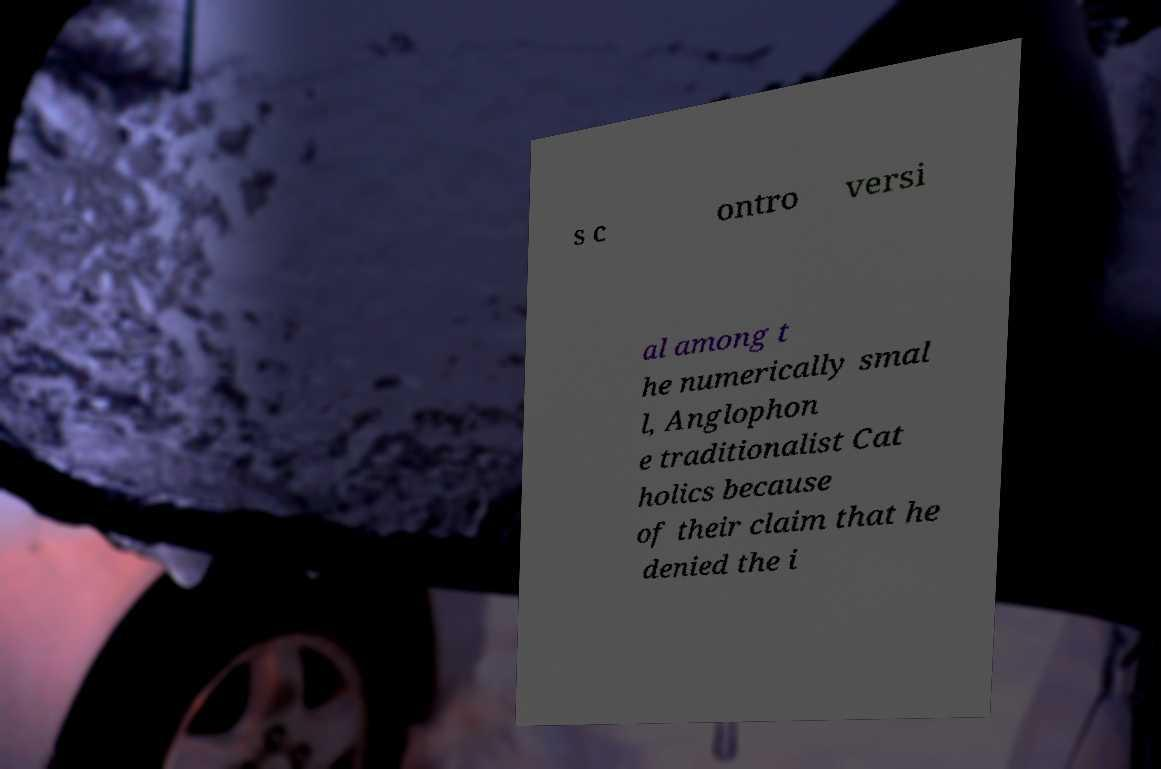Please identify and transcribe the text found in this image. s c ontro versi al among t he numerically smal l, Anglophon e traditionalist Cat holics because of their claim that he denied the i 